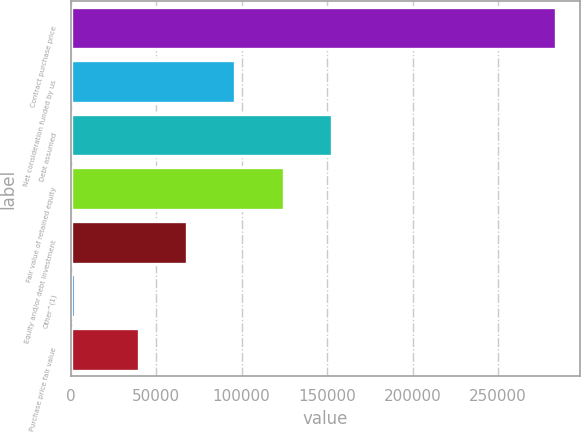<chart> <loc_0><loc_0><loc_500><loc_500><bar_chart><fcel>Contract purchase price<fcel>Net consideration funded by us<fcel>Debt assumed<fcel>Fair value of retained equity<fcel>Equity and/or debt investment<fcel>Other^(1)<fcel>Purchase price fair value<nl><fcel>284000<fcel>96371.4<fcel>152665<fcel>124518<fcel>68224.7<fcel>2533<fcel>40078<nl></chart> 